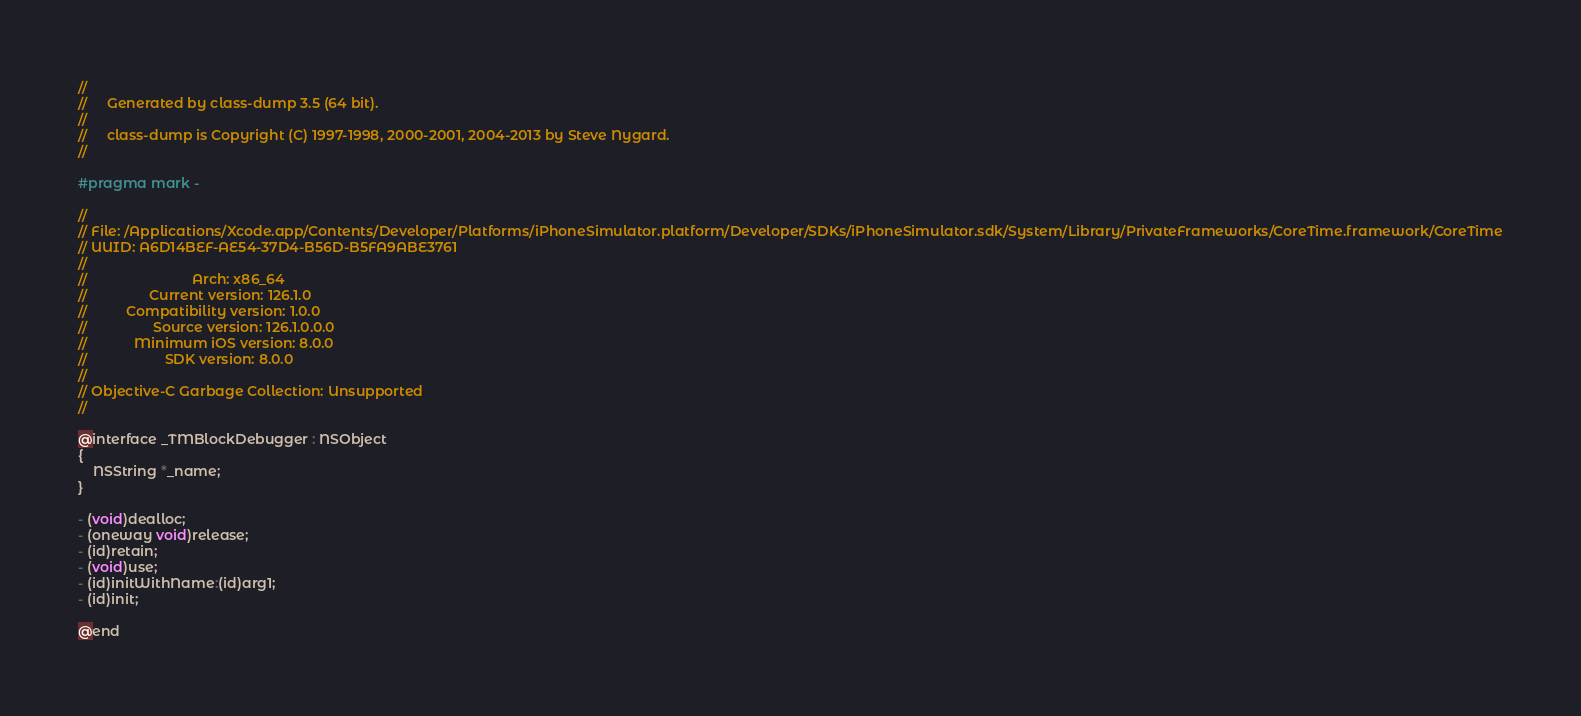<code> <loc_0><loc_0><loc_500><loc_500><_C_>//
//     Generated by class-dump 3.5 (64 bit).
//
//     class-dump is Copyright (C) 1997-1998, 2000-2001, 2004-2013 by Steve Nygard.
//

#pragma mark -

//
// File: /Applications/Xcode.app/Contents/Developer/Platforms/iPhoneSimulator.platform/Developer/SDKs/iPhoneSimulator.sdk/System/Library/PrivateFrameworks/CoreTime.framework/CoreTime
// UUID: A6D14BEF-AE54-37D4-B56D-B5FA9ABE3761
//
//                           Arch: x86_64
//                Current version: 126.1.0
//          Compatibility version: 1.0.0
//                 Source version: 126.1.0.0.0
//            Minimum iOS version: 8.0.0
//                    SDK version: 8.0.0
//
// Objective-C Garbage Collection: Unsupported
//

@interface _TMBlockDebugger : NSObject
{
    NSString *_name;
}

- (void)dealloc;
- (oneway void)release;
- (id)retain;
- (void)use;
- (id)initWithName:(id)arg1;
- (id)init;

@end

</code> 